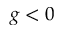<formula> <loc_0><loc_0><loc_500><loc_500>g < 0</formula> 